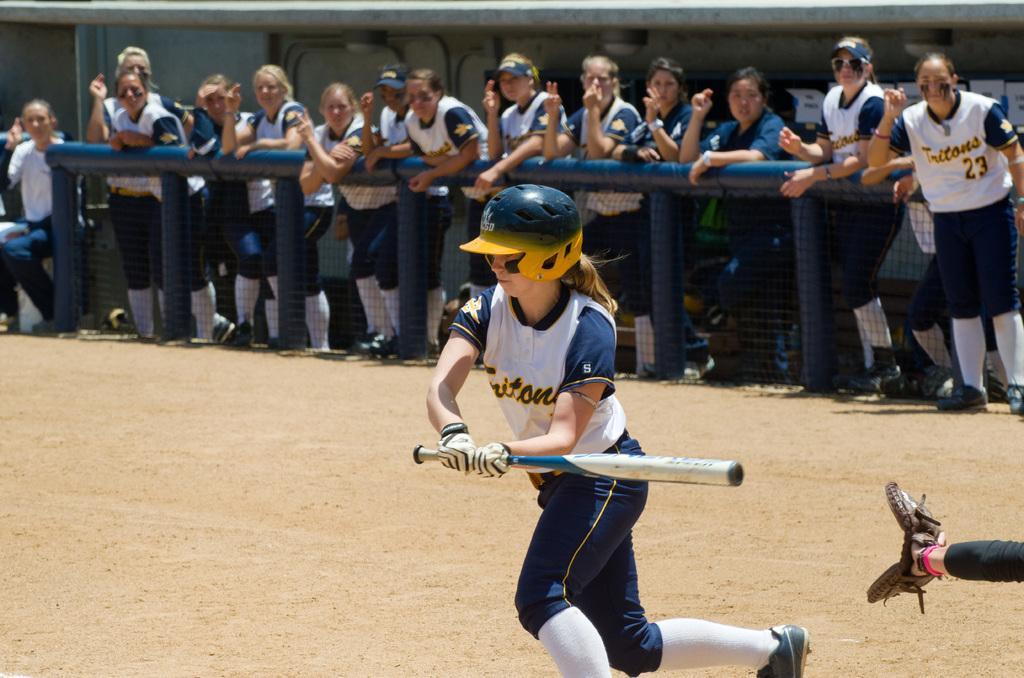Describe this image in one or two sentences. In front of the image there is a girl holding a baseball stick in her hand, behind her there is a person's hand with a glove, in the background of the image there are a few people standing, leaning on to a metal rod, behind them there is a wall with lamps on the rooftop. 